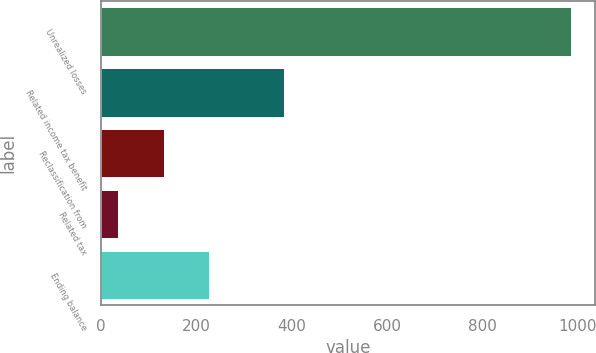Convert chart. <chart><loc_0><loc_0><loc_500><loc_500><bar_chart><fcel>Unrealized losses<fcel>Related income tax benefit<fcel>Reclassification from<fcel>Related tax<fcel>Ending balance<nl><fcel>986<fcel>384<fcel>131<fcel>36<fcel>226<nl></chart> 